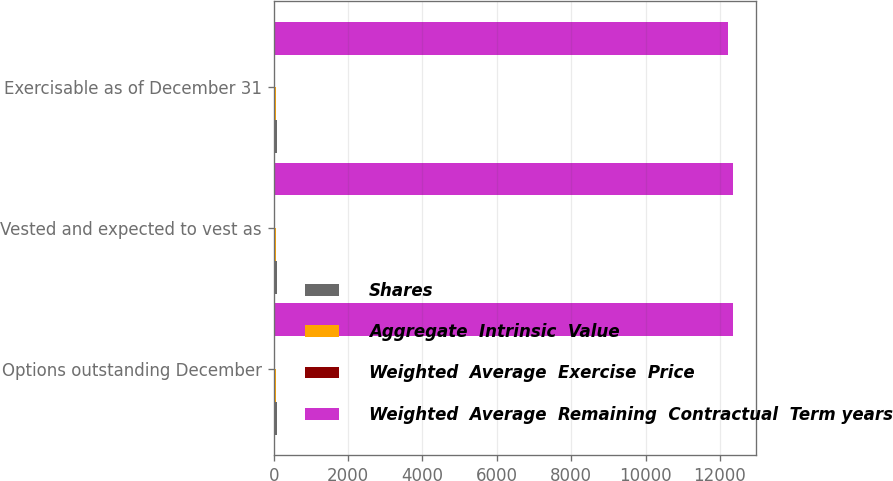Convert chart to OTSL. <chart><loc_0><loc_0><loc_500><loc_500><stacked_bar_chart><ecel><fcel>Options outstanding December<fcel>Vested and expected to vest as<fcel>Exercisable as of December 31<nl><fcel>Shares<fcel>91<fcel>91<fcel>90<nl><fcel>Aggregate  Intrinsic  Value<fcel>63.84<fcel>63.84<fcel>63.82<nl><fcel>Weighted  Average  Exercise  Price<fcel>4.9<fcel>4.9<fcel>4.9<nl><fcel>Weighted  Average  Remaining  Contractual  Term years<fcel>12360<fcel>12360<fcel>12227<nl></chart> 